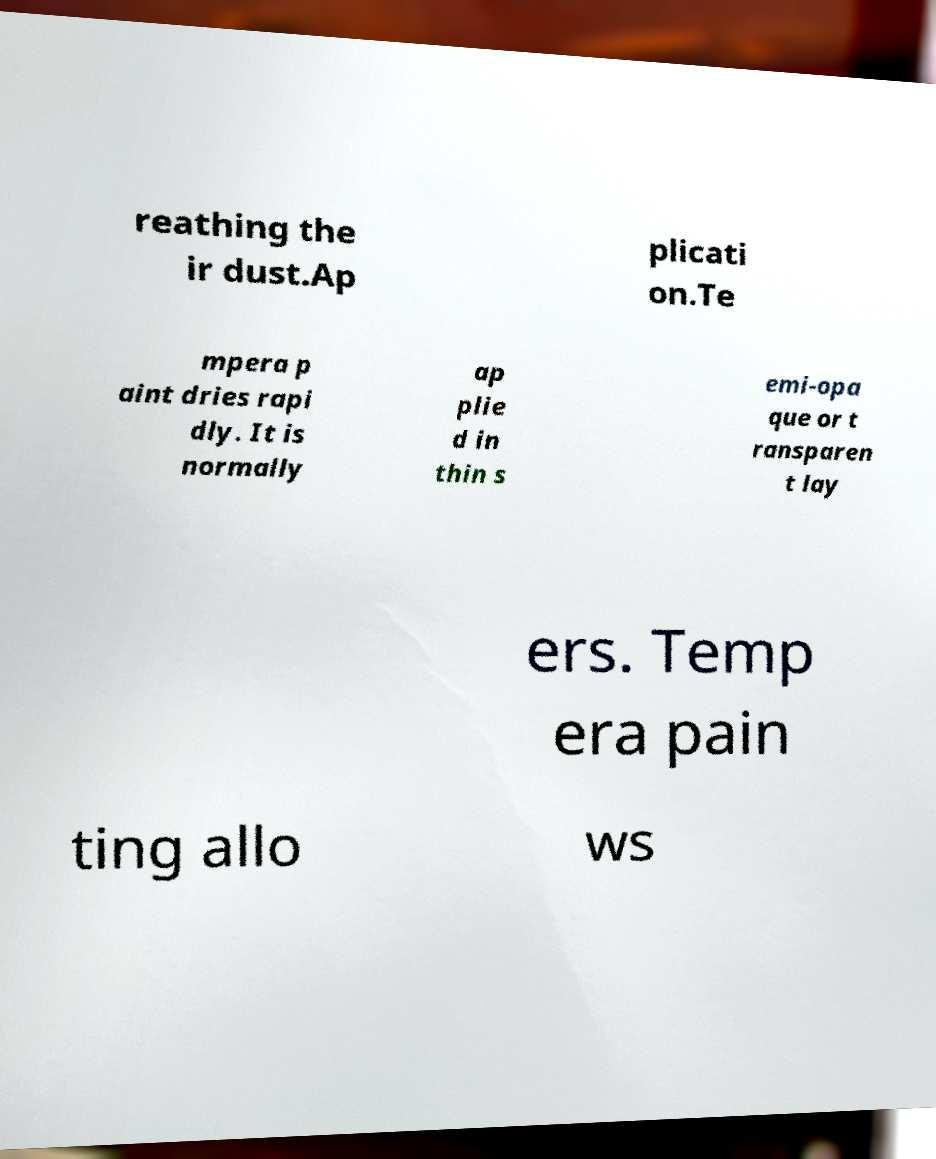Could you extract and type out the text from this image? reathing the ir dust.Ap plicati on.Te mpera p aint dries rapi dly. It is normally ap plie d in thin s emi-opa que or t ransparen t lay ers. Temp era pain ting allo ws 